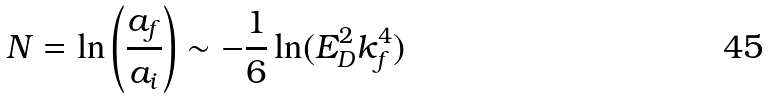Convert formula to latex. <formula><loc_0><loc_0><loc_500><loc_500>N = \ln \left ( \frac { a _ { f } } { a _ { i } } \right ) \sim - \frac { 1 } { 6 } \ln ( E _ { D } ^ { 2 } k _ { f } ^ { 4 } )</formula> 